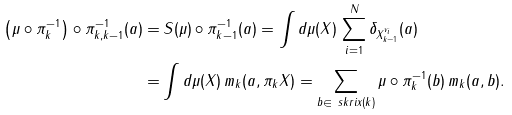Convert formula to latex. <formula><loc_0><loc_0><loc_500><loc_500>\left ( \mu \circ \pi _ { k } ^ { - 1 } \right ) \circ \pi _ { k , k - 1 } ^ { - 1 } ( a ) = & \, S ( \mu ) \circ \pi _ { k - 1 } ^ { - 1 } ( a ) = \int d \mu ( X ) \, \sum _ { i = 1 } ^ { N } \delta _ { X ^ { v _ { i } } _ { k - 1 } } ( a ) \\ = & \int d \mu ( X ) \, m _ { k } ( a , \pi _ { k } X ) = \sum _ { b \in \ s k r i x ( k ) } \mu \circ \pi _ { k } ^ { - 1 } ( b ) \, m _ { k } ( a , b ) .</formula> 